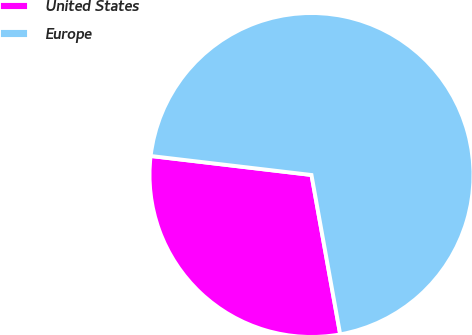Convert chart. <chart><loc_0><loc_0><loc_500><loc_500><pie_chart><fcel>United States<fcel>Europe<nl><fcel>29.71%<fcel>70.29%<nl></chart> 